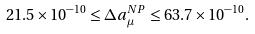Convert formula to latex. <formula><loc_0><loc_0><loc_500><loc_500>2 1 . 5 \times 1 0 ^ { - 1 0 } \leq \Delta a _ { \mu } ^ { N P } \leq 6 3 . 7 \times 1 0 ^ { - 1 0 } .</formula> 